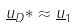<formula> <loc_0><loc_0><loc_500><loc_500>\underline { u } _ { D } * \approx \underline { u } _ { 1 }</formula> 